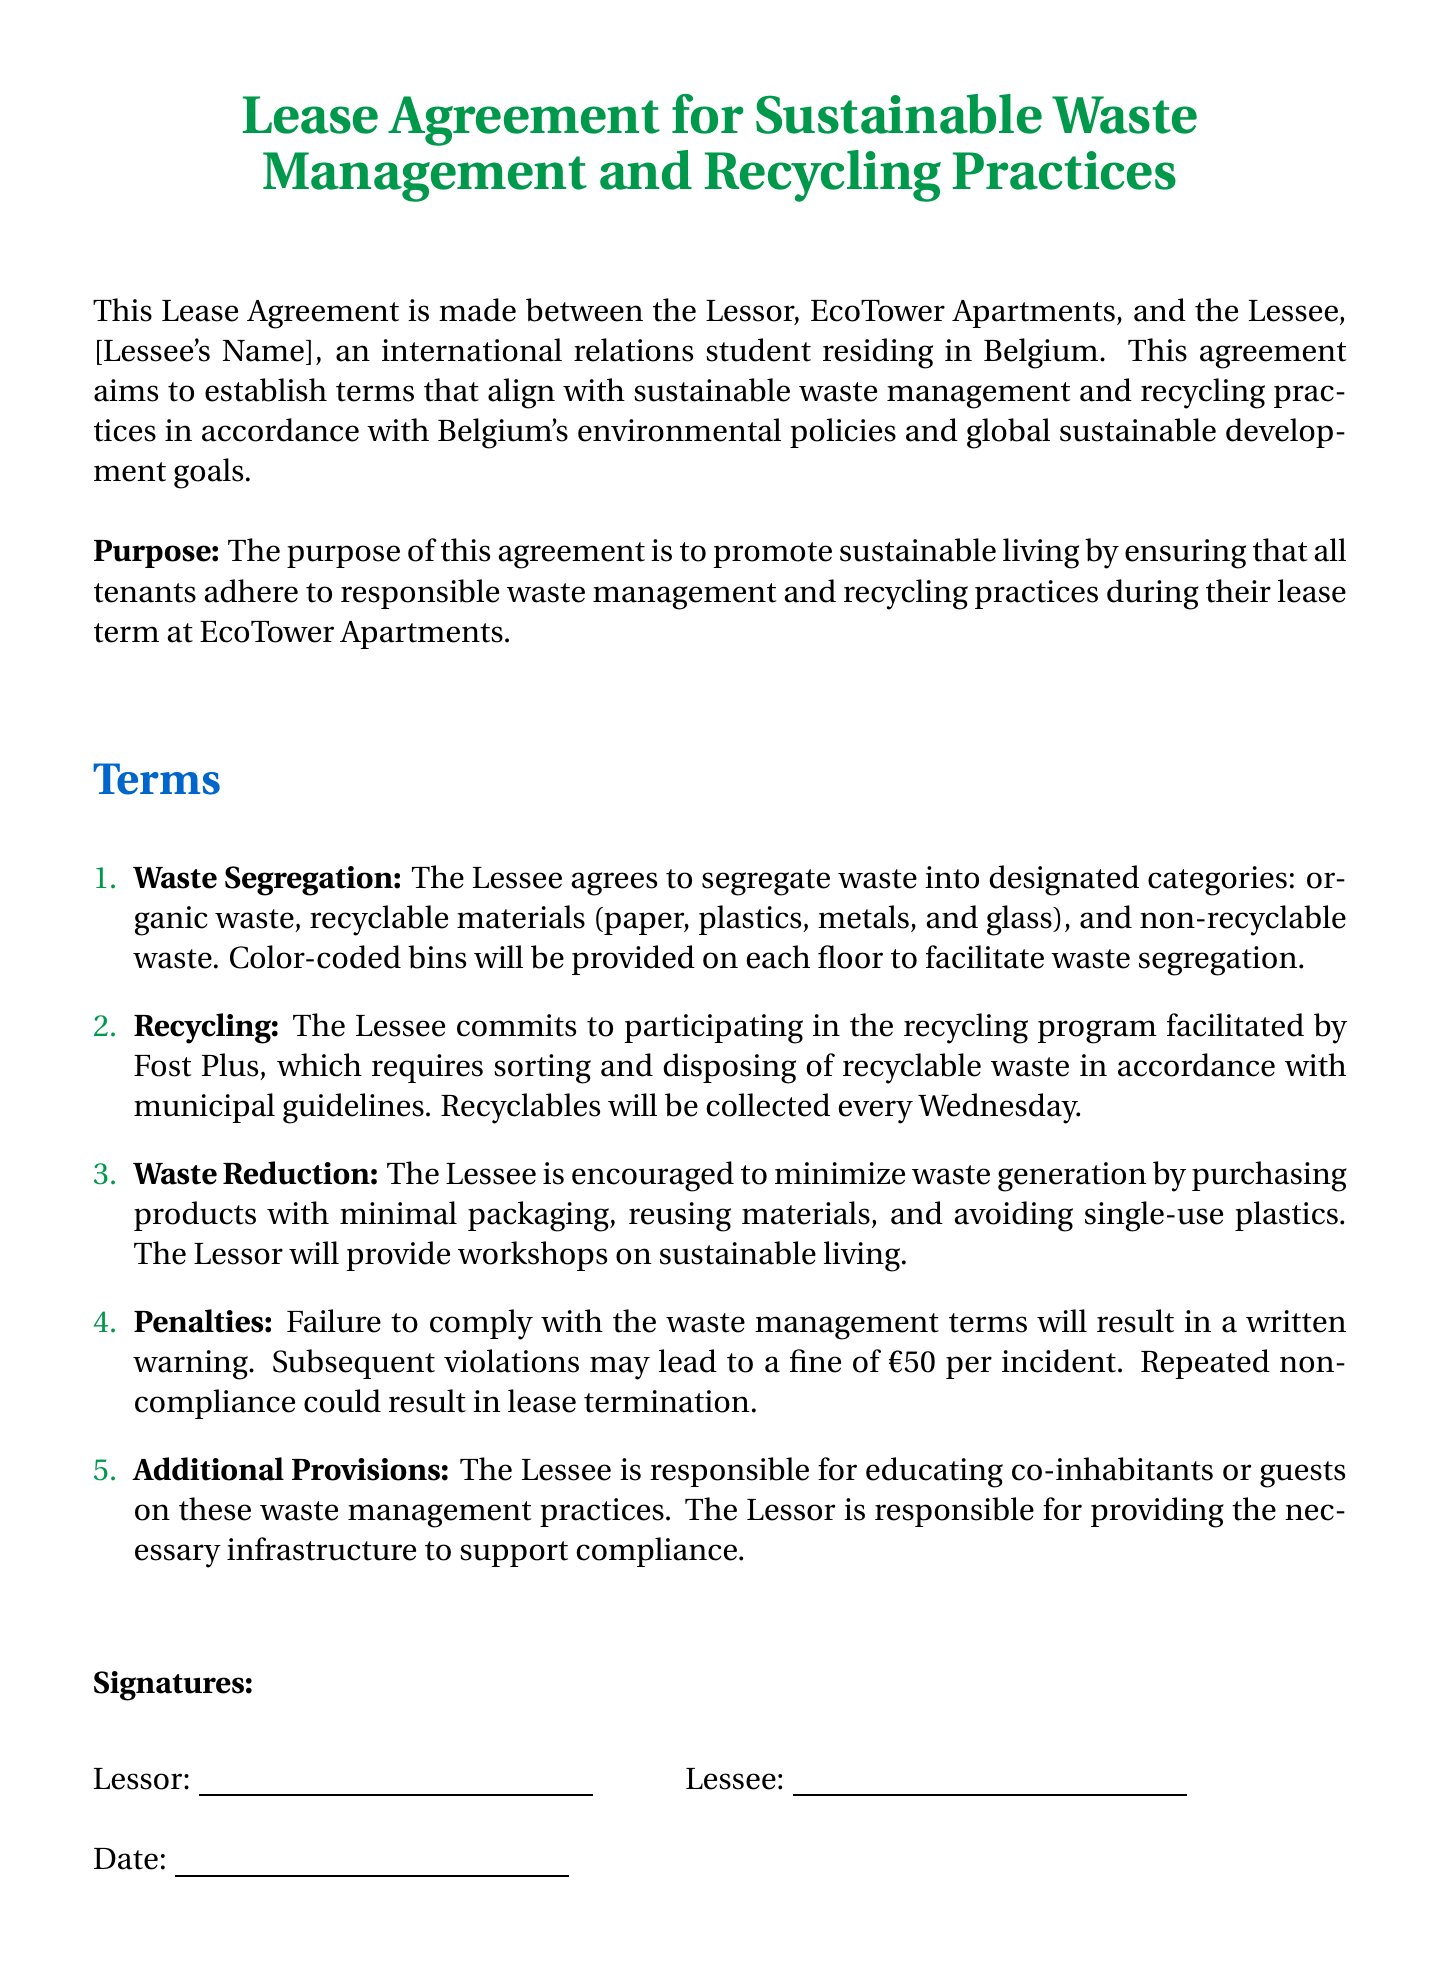What is the title of the document? The title of the document is stated prominently at the beginning of the lease agreement.
Answer: Lease Agreement for Sustainable Waste Management and Recycling Practices Who are the parties involved in this agreement? The parties involved are specified in the introductory section of the document.
Answer: EcoTower Apartments and [Lessee's Name] What type of waste must the Lessee segregate? The agreement lists specific categories for waste segregation in the first term.
Answer: Organic waste, recyclable materials, and non-recyclable waste When are recyclables collected? The document mentions a specific day for the collection of recyclables in the recycling provision.
Answer: Every Wednesday What is the penalty for a first violation of the waste management terms? The document outlines consequences for failing to comply with the waste management terms in the penalties section.
Answer: A written warning What does the Lessee need to educate others about? The document specifies what the Lessee's responsibility includes in terms of communication with others.
Answer: Waste management practices How much is the fine for repeated non-compliance? The penalties section highlights the amount of the fine for subsequent violations.
Answer: €50 per incident What is the Lessee encouraged to minimize? The third term encourages a specific behavior regarding waste generation.
Answer: Waste generation What responsibility does the Lessor have in this agreement? The document outlines the responsibilities of the Lessor in relation to supporting the Lessee's compliance.
Answer: Providing the necessary infrastructure 